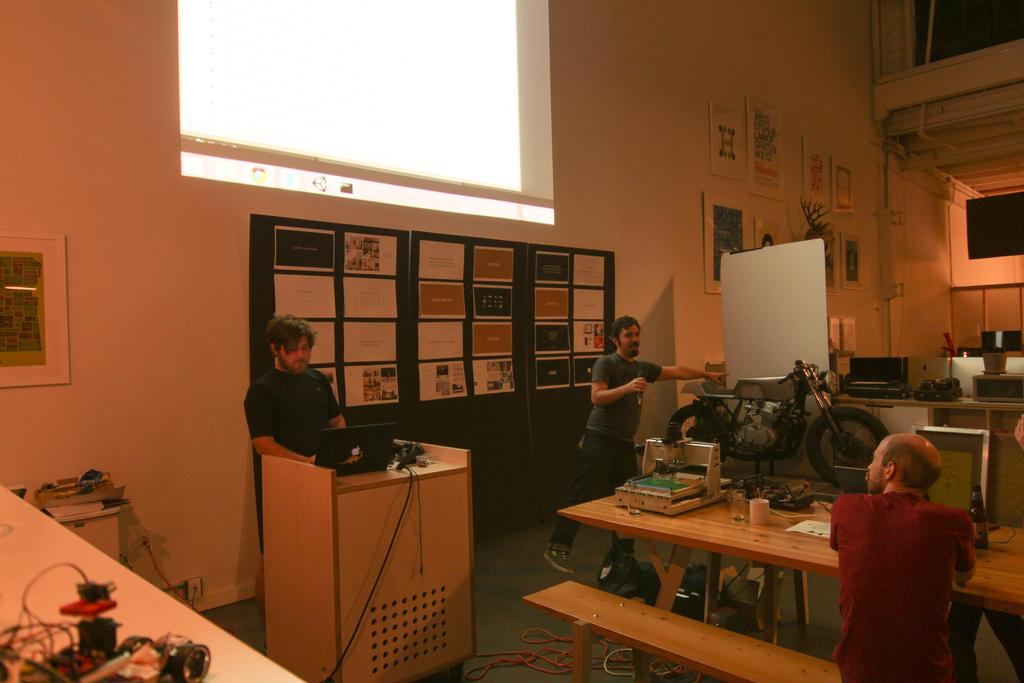How many people are in the image? There are three persons in the image. What are the positions of the people in the image? Two of the persons are standing, and one person is sitting on a bench. What scent can be detected from the people in the image? There is no information about the scent of the people in the image, so it cannot be determined. 